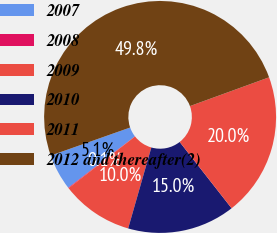<chart> <loc_0><loc_0><loc_500><loc_500><pie_chart><fcel>2007<fcel>2008<fcel>2009<fcel>2010<fcel>2011<fcel>2012 and thereafter(2)<nl><fcel>5.05%<fcel>0.08%<fcel>10.03%<fcel>15.01%<fcel>19.98%<fcel>49.85%<nl></chart> 